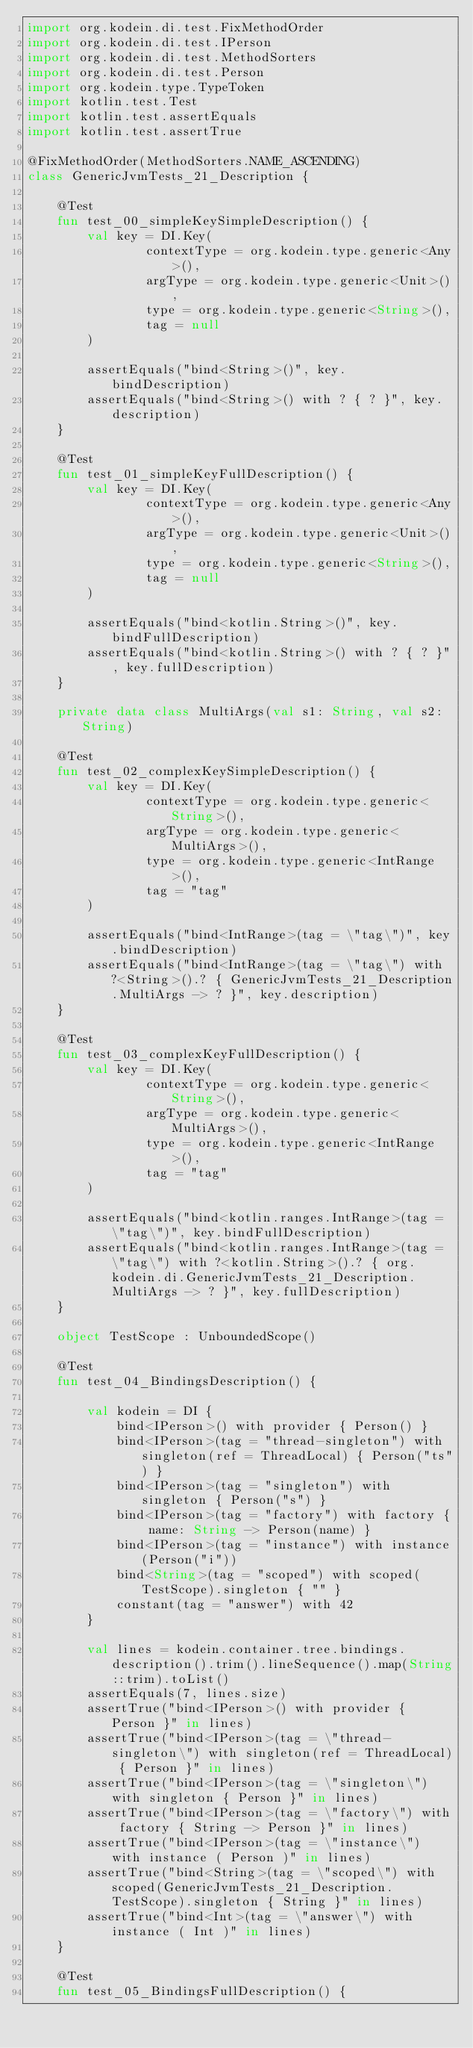<code> <loc_0><loc_0><loc_500><loc_500><_Kotlin_>import org.kodein.di.test.FixMethodOrder
import org.kodein.di.test.IPerson
import org.kodein.di.test.MethodSorters
import org.kodein.di.test.Person
import org.kodein.type.TypeToken
import kotlin.test.Test
import kotlin.test.assertEquals
import kotlin.test.assertTrue

@FixMethodOrder(MethodSorters.NAME_ASCENDING)
class GenericJvmTests_21_Description {

    @Test
    fun test_00_simpleKeySimpleDescription() {
        val key = DI.Key(
                contextType = org.kodein.type.generic<Any>(),
                argType = org.kodein.type.generic<Unit>(),
                type = org.kodein.type.generic<String>(),
                tag = null
        )

        assertEquals("bind<String>()", key.bindDescription)
        assertEquals("bind<String>() with ? { ? }", key.description)
    }

    @Test
    fun test_01_simpleKeyFullDescription() {
        val key = DI.Key(
                contextType = org.kodein.type.generic<Any>(),
                argType = org.kodein.type.generic<Unit>(),
                type = org.kodein.type.generic<String>(),
                tag = null
        )

        assertEquals("bind<kotlin.String>()", key.bindFullDescription)
        assertEquals("bind<kotlin.String>() with ? { ? }", key.fullDescription)
    }

    private data class MultiArgs(val s1: String, val s2: String)

    @Test
    fun test_02_complexKeySimpleDescription() {
        val key = DI.Key(
                contextType = org.kodein.type.generic<String>(),
                argType = org.kodein.type.generic<MultiArgs>(),
                type = org.kodein.type.generic<IntRange>(),
                tag = "tag"
        )

        assertEquals("bind<IntRange>(tag = \"tag\")", key.bindDescription)
        assertEquals("bind<IntRange>(tag = \"tag\") with ?<String>().? { GenericJvmTests_21_Description.MultiArgs -> ? }", key.description)
    }

    @Test
    fun test_03_complexKeyFullDescription() {
        val key = DI.Key(
                contextType = org.kodein.type.generic<String>(),
                argType = org.kodein.type.generic<MultiArgs>(),
                type = org.kodein.type.generic<IntRange>(),
                tag = "tag"
        )

        assertEquals("bind<kotlin.ranges.IntRange>(tag = \"tag\")", key.bindFullDescription)
        assertEquals("bind<kotlin.ranges.IntRange>(tag = \"tag\") with ?<kotlin.String>().? { org.kodein.di.GenericJvmTests_21_Description.MultiArgs -> ? }", key.fullDescription)
    }

    object TestScope : UnboundedScope()

    @Test
    fun test_04_BindingsDescription() {

        val kodein = DI {
            bind<IPerson>() with provider { Person() }
            bind<IPerson>(tag = "thread-singleton") with singleton(ref = ThreadLocal) { Person("ts") }
            bind<IPerson>(tag = "singleton") with singleton { Person("s") }
            bind<IPerson>(tag = "factory") with factory { name: String -> Person(name) }
            bind<IPerson>(tag = "instance") with instance(Person("i"))
            bind<String>(tag = "scoped") with scoped(TestScope).singleton { "" }
            constant(tag = "answer") with 42
        }

        val lines = kodein.container.tree.bindings.description().trim().lineSequence().map(String::trim).toList()
        assertEquals(7, lines.size)
        assertTrue("bind<IPerson>() with provider { Person }" in lines)
        assertTrue("bind<IPerson>(tag = \"thread-singleton\") with singleton(ref = ThreadLocal) { Person }" in lines)
        assertTrue("bind<IPerson>(tag = \"singleton\") with singleton { Person }" in lines)
        assertTrue("bind<IPerson>(tag = \"factory\") with factory { String -> Person }" in lines)
        assertTrue("bind<IPerson>(tag = \"instance\") with instance ( Person )" in lines)
        assertTrue("bind<String>(tag = \"scoped\") with scoped(GenericJvmTests_21_Description.TestScope).singleton { String }" in lines)
        assertTrue("bind<Int>(tag = \"answer\") with instance ( Int )" in lines)
    }

    @Test
    fun test_05_BindingsFullDescription() {
</code> 